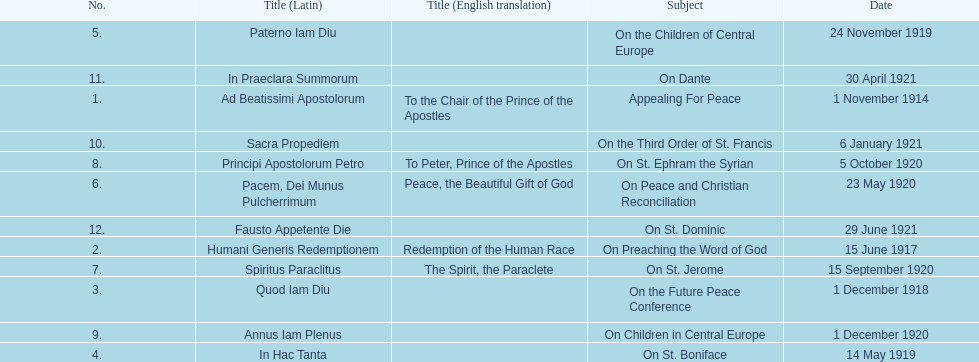How many titles did not have an english translation listed? 7. 